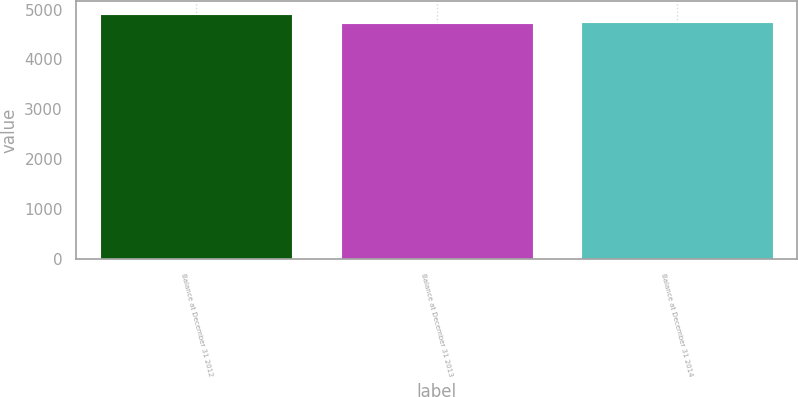Convert chart to OTSL. <chart><loc_0><loc_0><loc_500><loc_500><bar_chart><fcel>Balance at December 31 2012<fcel>Balance at December 31 2013<fcel>Balance at December 31 2014<nl><fcel>4918<fcel>4740<fcel>4757.8<nl></chart> 